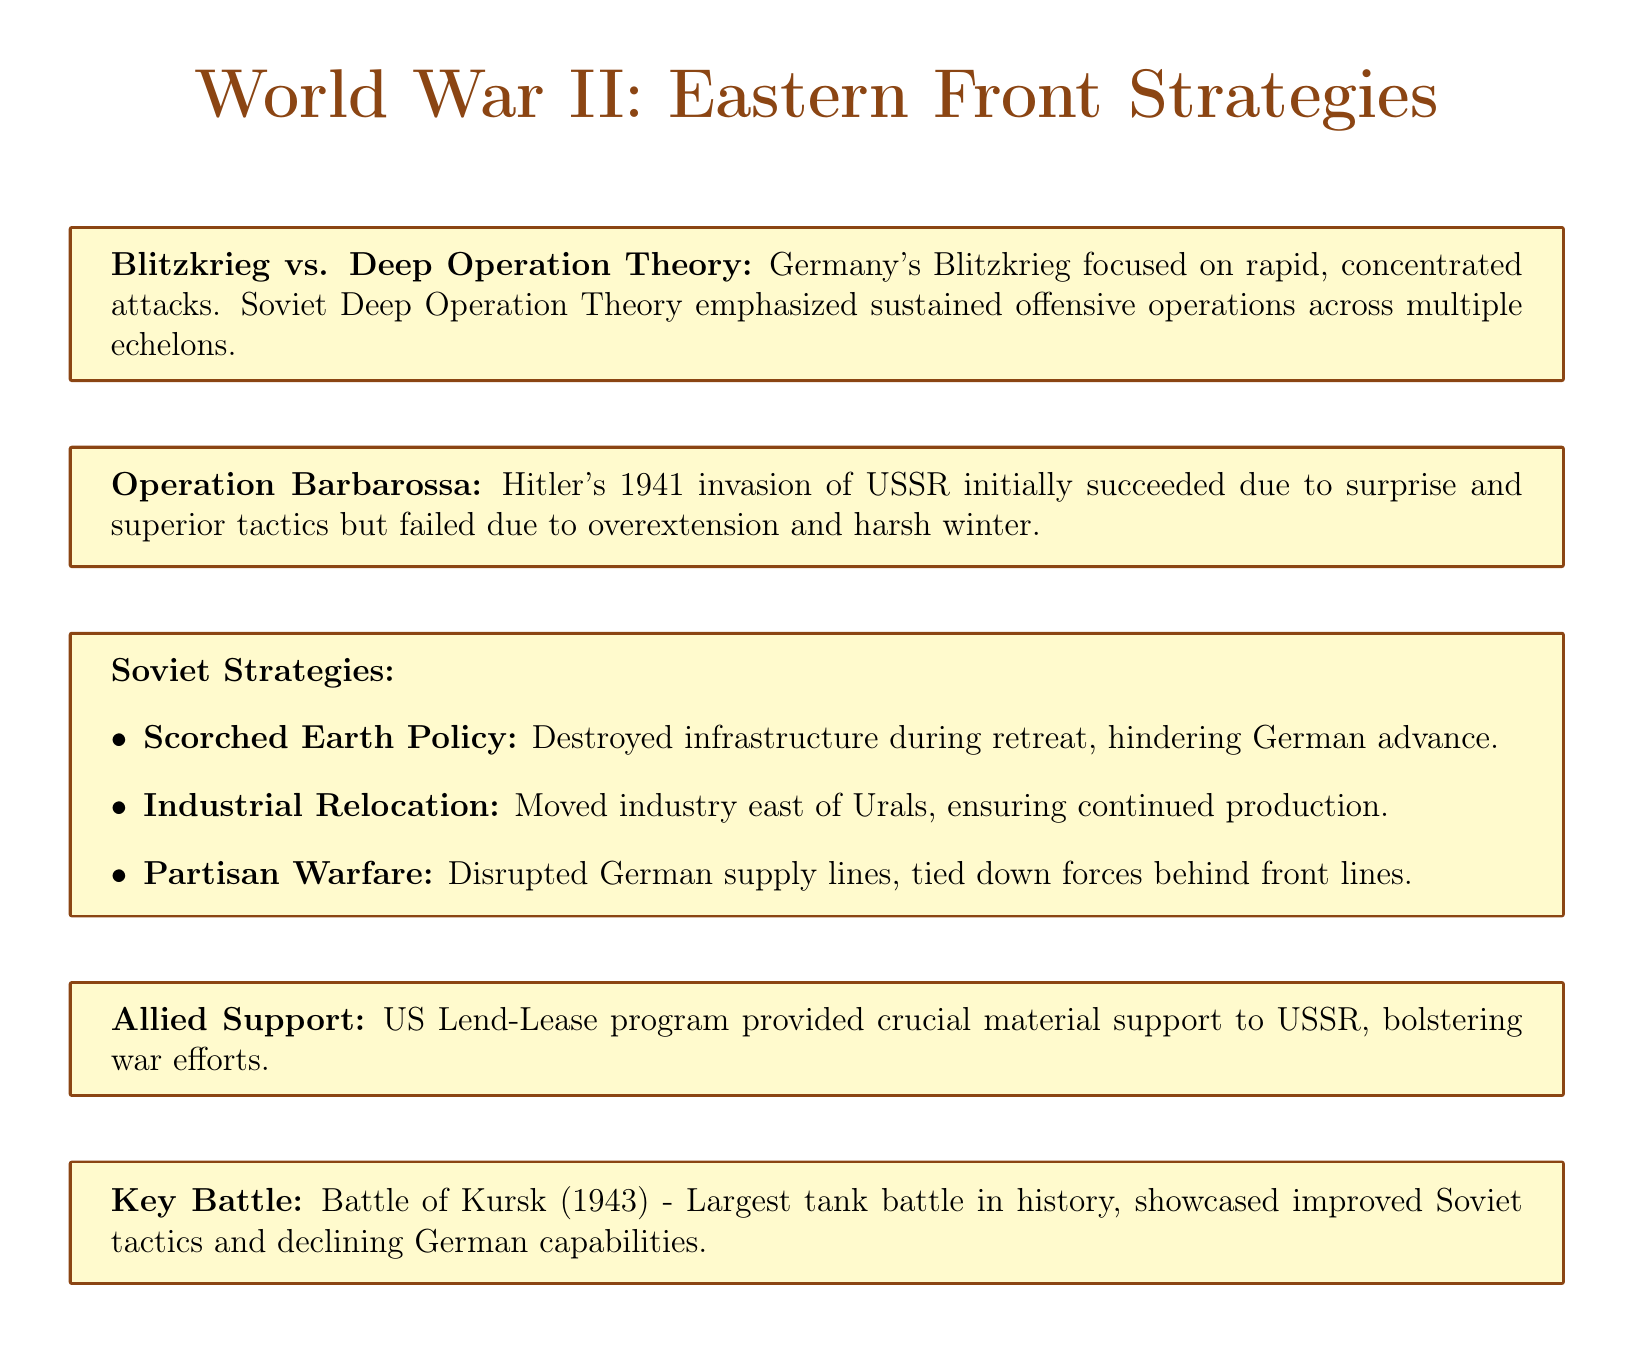What is the title of the strategy employed by Germany? The title refers to the military strategy employed by Germany, known as "Blitzkrieg."
Answer: Blitzkrieg Who developed the Soviet Deep Operation Theory? The document states that Mikhail Tukhachevsky developed the Soviet Deep Operation Theory.
Answer: Mikhail Tukhachevsky What year did Operation Barbarossa take place? Operation Barbarossa is mentioned in the context of Hitler's invasion of the Soviet Union occurring in 1941.
Answer: 1941 What strategy did the Soviets use to hinder German advances during their retreat? The document describes the Soviet Scorched Earth Policy as the strategy employed to hinder German advances.
Answer: Scorched Earth Policy Which battle is noted as the largest tank battle in history? The Battle of Kursk is identified in the document as the largest tank battle in history.
Answer: Battle of Kursk How did the Soviets ensure continued war production during the conflict? The Soviets successfully relocated their industry east of the Ural Mountains to ensure continued production during the war.
Answer: Industrial Relocation How did the US support the Soviet Union during World War II? The document highlights the US Lend-Lease program as crucial material support provided to the Soviet Union during the war.
Answer: Lend-Lease program What effect did Soviet partisans have on German forces? The document states that Soviet partisans disrupted German supply lines and tied down significant German forces.
Answer: Disrupted German supply lines In what year did the Battle of Kursk occur? The document specifies that the Battle of Kursk occurred in 1943.
Answer: 1943 